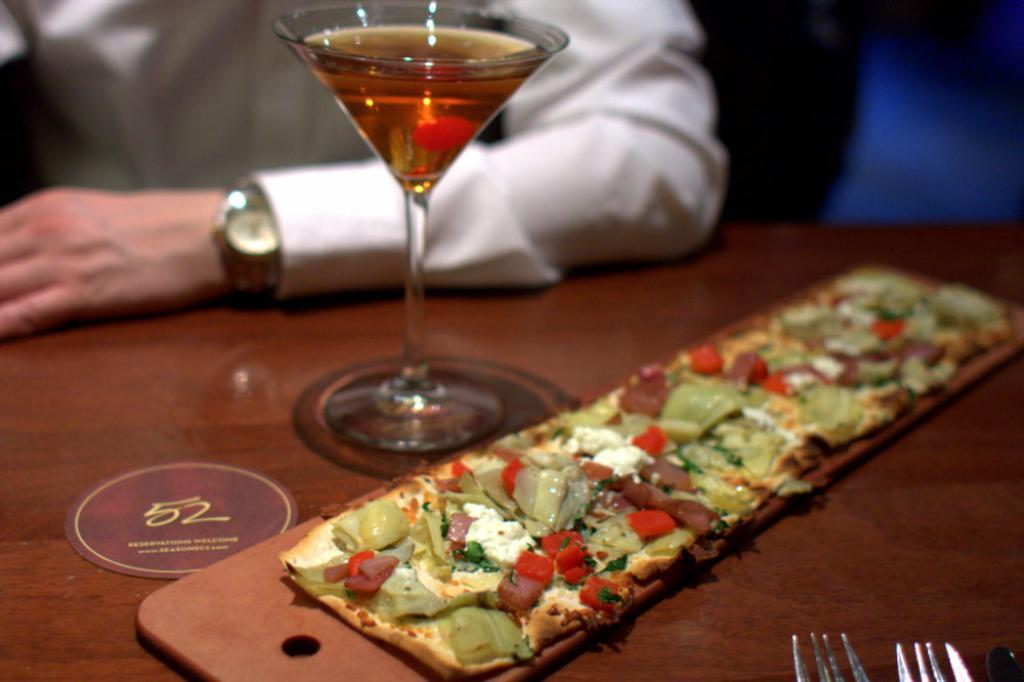What type of table is in the image? There is a wooden table in the image. What is on the table? There are items placed on the table. Can you describe anything in the background of the image? In the background, there is a human hand visible. What is the person wearing in the image? The person has a white shirt on and is wearing a watch. Is the person celebrating their birthday in the image? There is no indication in the image that the person is celebrating their birthday. Is the person in jail in the image? There is no indication in the image that the person is in jail. What is the person's level of wealth in the image? There is no information about the person's wealth in the image. 